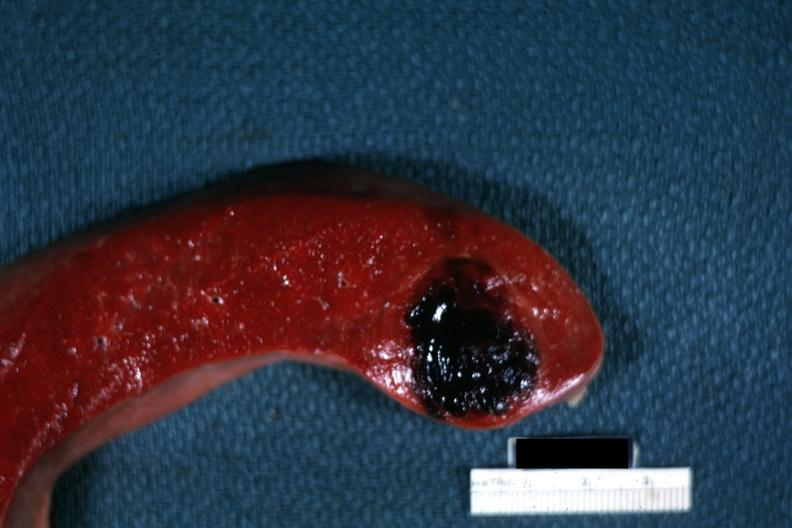what is present?
Answer the question using a single word or phrase. Hematologic 